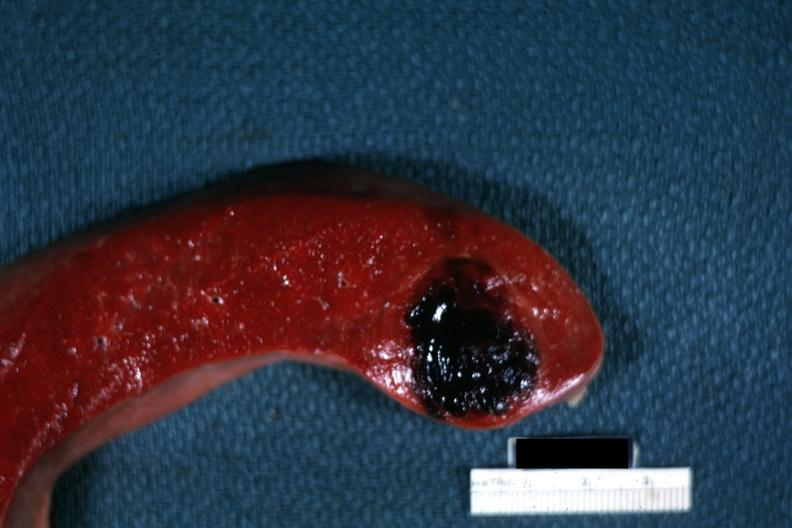what is present?
Answer the question using a single word or phrase. Hematologic 